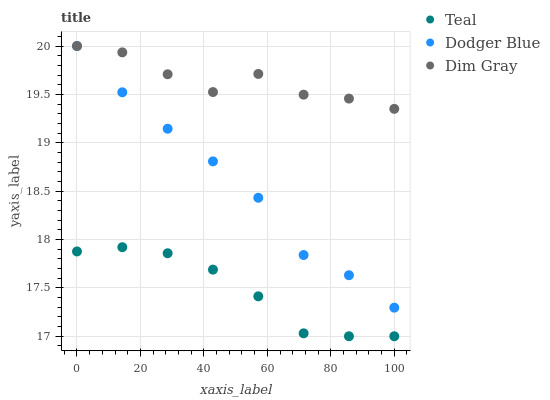Does Teal have the minimum area under the curve?
Answer yes or no. Yes. Does Dim Gray have the maximum area under the curve?
Answer yes or no. Yes. Does Dodger Blue have the minimum area under the curve?
Answer yes or no. No. Does Dodger Blue have the maximum area under the curve?
Answer yes or no. No. Is Teal the smoothest?
Answer yes or no. Yes. Is Dim Gray the roughest?
Answer yes or no. Yes. Is Dodger Blue the smoothest?
Answer yes or no. No. Is Dodger Blue the roughest?
Answer yes or no. No. Does Teal have the lowest value?
Answer yes or no. Yes. Does Dodger Blue have the lowest value?
Answer yes or no. No. Does Dodger Blue have the highest value?
Answer yes or no. Yes. Does Teal have the highest value?
Answer yes or no. No. Is Teal less than Dodger Blue?
Answer yes or no. Yes. Is Dodger Blue greater than Teal?
Answer yes or no. Yes. Does Dim Gray intersect Dodger Blue?
Answer yes or no. Yes. Is Dim Gray less than Dodger Blue?
Answer yes or no. No. Is Dim Gray greater than Dodger Blue?
Answer yes or no. No. Does Teal intersect Dodger Blue?
Answer yes or no. No. 